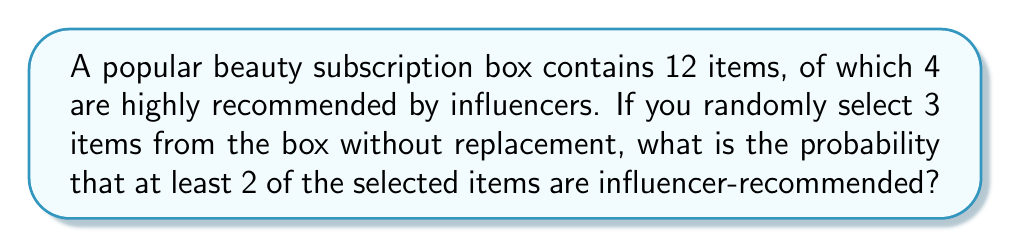Solve this math problem. Let's approach this step-by-step:

1) First, we need to calculate the total number of ways to select 3 items from 12. This is given by the combination formula:

   $$\binom{12}{3} = \frac{12!}{3!(12-3)!} = \frac{12!}{3!9!} = 220$$

2) Now, we need to calculate the number of favorable outcomes. There are two cases that satisfy our condition:
   a) Exactly 2 recommended items and 1 non-recommended item
   b) All 3 items are recommended

3) For case a:
   - Choose 2 from 4 recommended items: $\binom{4}{2} = 6$
   - Choose 1 from 8 non-recommended items: $\binom{8}{1} = 8$
   - Total combinations: $6 \times 8 = 48$

4) For case b:
   - Choose 3 from 4 recommended items: $\binom{4}{3} = 4$

5) Total favorable outcomes: $48 + 4 = 52$

6) The probability is then:

   $$P(\text{at least 2 recommended}) = \frac{\text{favorable outcomes}}{\text{total outcomes}} = \frac{52}{220} = \frac{13}{55} \approx 0.2364$$
Answer: $\frac{13}{55}$ 